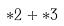Convert formula to latex. <formula><loc_0><loc_0><loc_500><loc_500>* 2 + * 3</formula> 